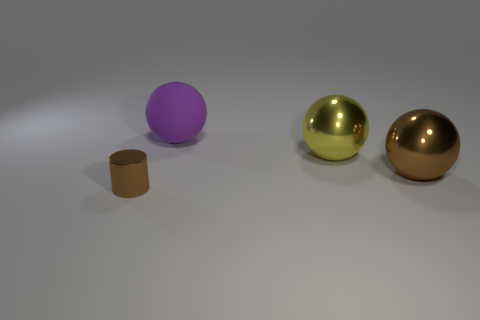Add 3 big balls. How many objects exist? 7 Subtract all balls. How many objects are left? 1 Subtract 0 green cubes. How many objects are left? 4 Subtract all cylinders. Subtract all yellow shiny things. How many objects are left? 2 Add 1 yellow metallic spheres. How many yellow metallic spheres are left? 2 Add 3 big brown metallic objects. How many big brown metallic objects exist? 4 